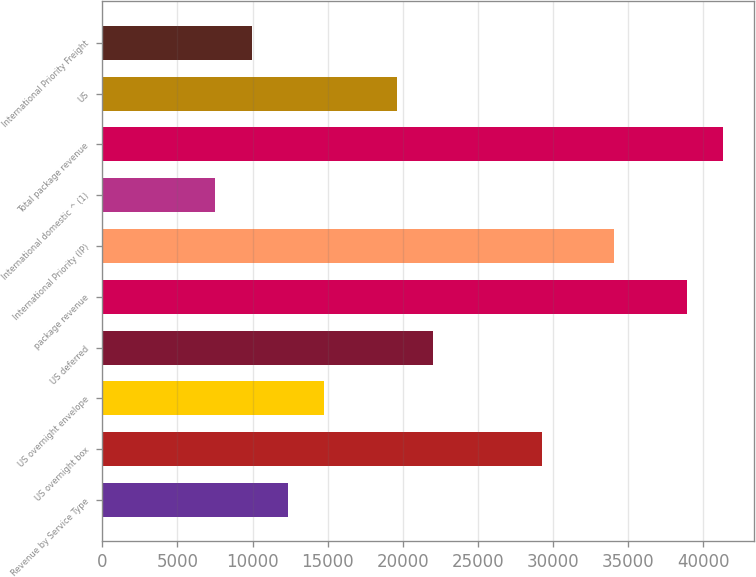Convert chart to OTSL. <chart><loc_0><loc_0><loc_500><loc_500><bar_chart><fcel>Revenue by Service Type<fcel>US overnight box<fcel>US overnight envelope<fcel>US deferred<fcel>package revenue<fcel>International Priority (IP)<fcel>International domestic ^ (1)<fcel>Total package revenue<fcel>US<fcel>International Priority Freight<nl><fcel>12356<fcel>29247<fcel>14769<fcel>22008<fcel>38899<fcel>34073<fcel>7530<fcel>41312<fcel>19595<fcel>9943<nl></chart> 